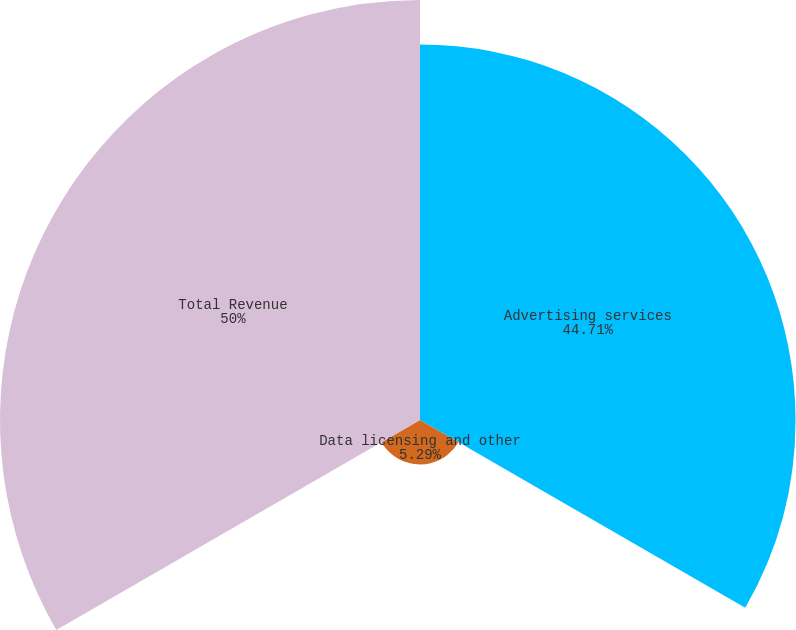<chart> <loc_0><loc_0><loc_500><loc_500><pie_chart><fcel>Advertising services<fcel>Data licensing and other<fcel>Total Revenue<nl><fcel>44.71%<fcel>5.29%<fcel>50.0%<nl></chart> 